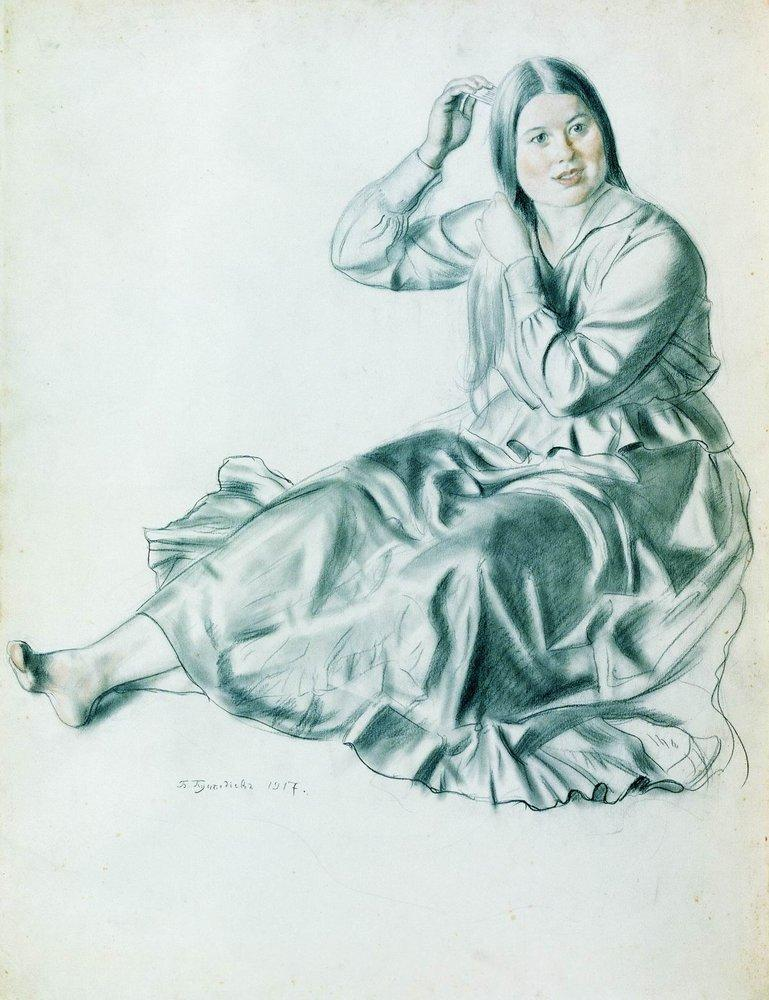What might be the historical context of this artwork? The artwork, dated 1917, was created during a period marked by great global upheaval due to World War I. Despite the chaos of the outside world, this sketch captures a moment of personal tranquility and introspection, suggesting that the subjects and everyday life continued in spite of the larger historical context. The clothing style, with a long dress, reflects the fashion of the early 20th century. The choice of a young woman as the subject could also signify the resilience and strength found in ordinary people during difficult times. 